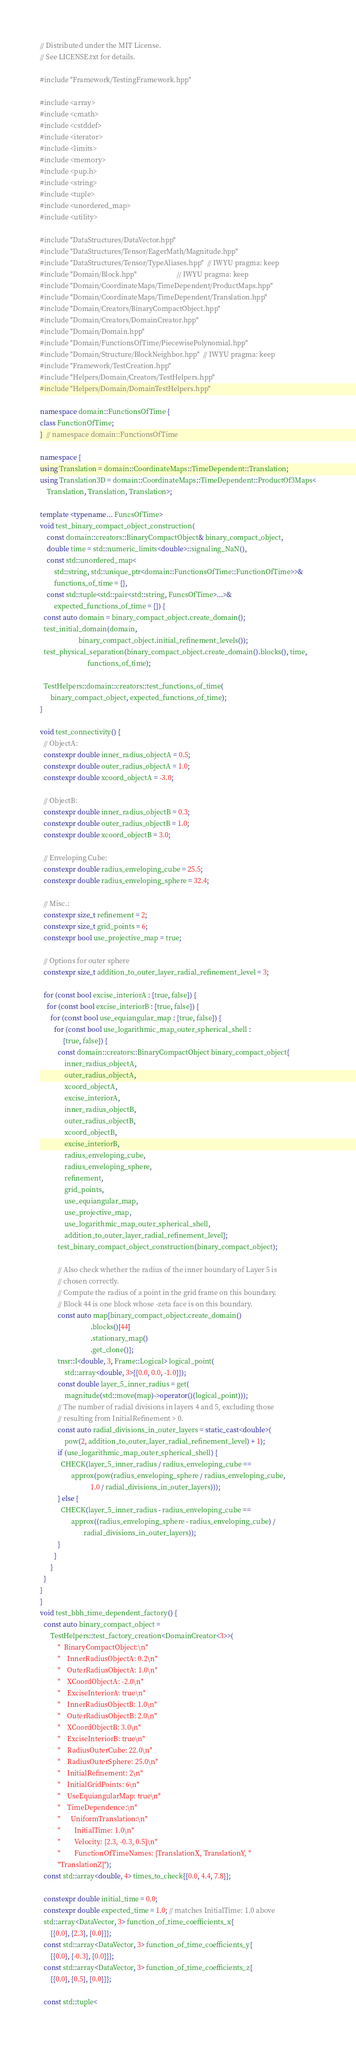Convert code to text. <code><loc_0><loc_0><loc_500><loc_500><_C++_>// Distributed under the MIT License.
// See LICENSE.txt for details.

#include "Framework/TestingFramework.hpp"

#include <array>
#include <cmath>
#include <cstddef>
#include <iterator>
#include <limits>
#include <memory>
#include <pup.h>
#include <string>
#include <tuple>
#include <unordered_map>
#include <utility>

#include "DataStructures/DataVector.hpp"
#include "DataStructures/Tensor/EagerMath/Magnitude.hpp"
#include "DataStructures/Tensor/TypeAliases.hpp"  // IWYU pragma: keep
#include "Domain/Block.hpp"                       // IWYU pragma: keep
#include "Domain/CoordinateMaps/TimeDependent/ProductMaps.hpp"
#include "Domain/CoordinateMaps/TimeDependent/Translation.hpp"
#include "Domain/Creators/BinaryCompactObject.hpp"
#include "Domain/Creators/DomainCreator.hpp"
#include "Domain/Domain.hpp"
#include "Domain/FunctionsOfTime/PiecewisePolynomial.hpp"
#include "Domain/Structure/BlockNeighbor.hpp"  // IWYU pragma: keep
#include "Framework/TestCreation.hpp"
#include "Helpers/Domain/Creators/TestHelpers.hpp"
#include "Helpers/Domain/DomainTestHelpers.hpp"

namespace domain::FunctionsOfTime {
class FunctionOfTime;
}  // namespace domain::FunctionsOfTime

namespace {
using Translation = domain::CoordinateMaps::TimeDependent::Translation;
using Translation3D = domain::CoordinateMaps::TimeDependent::ProductOf3Maps<
    Translation, Translation, Translation>;

template <typename... FuncsOfTime>
void test_binary_compact_object_construction(
    const domain::creators::BinaryCompactObject& binary_compact_object,
    double time = std::numeric_limits<double>::signaling_NaN(),
    const std::unordered_map<
        std::string, std::unique_ptr<domain::FunctionsOfTime::FunctionOfTime>>&
        functions_of_time = {},
    const std::tuple<std::pair<std::string, FuncsOfTime>...>&
        expected_functions_of_time = {}) {
  const auto domain = binary_compact_object.create_domain();
  test_initial_domain(domain,
                      binary_compact_object.initial_refinement_levels());
  test_physical_separation(binary_compact_object.create_domain().blocks(), time,
                           functions_of_time);

  TestHelpers::domain::creators::test_functions_of_time(
      binary_compact_object, expected_functions_of_time);
}

void test_connectivity() {
  // ObjectA:
  constexpr double inner_radius_objectA = 0.5;
  constexpr double outer_radius_objectA = 1.0;
  constexpr double xcoord_objectA = -3.0;

  // ObjectB:
  constexpr double inner_radius_objectB = 0.3;
  constexpr double outer_radius_objectB = 1.0;
  constexpr double xcoord_objectB = 3.0;

  // Enveloping Cube:
  constexpr double radius_enveloping_cube = 25.5;
  constexpr double radius_enveloping_sphere = 32.4;

  // Misc.:
  constexpr size_t refinement = 2;
  constexpr size_t grid_points = 6;
  constexpr bool use_projective_map = true;

  // Options for outer sphere
  constexpr size_t addition_to_outer_layer_radial_refinement_level = 3;

  for (const bool excise_interiorA : {true, false}) {
    for (const bool excise_interiorB : {true, false}) {
      for (const bool use_equiangular_map : {true, false}) {
        for (const bool use_logarithmic_map_outer_spherical_shell :
             {true, false}) {
          const domain::creators::BinaryCompactObject binary_compact_object{
              inner_radius_objectA,
              outer_radius_objectA,
              xcoord_objectA,
              excise_interiorA,
              inner_radius_objectB,
              outer_radius_objectB,
              xcoord_objectB,
              excise_interiorB,
              radius_enveloping_cube,
              radius_enveloping_sphere,
              refinement,
              grid_points,
              use_equiangular_map,
              use_projective_map,
              use_logarithmic_map_outer_spherical_shell,
              addition_to_outer_layer_radial_refinement_level};
          test_binary_compact_object_construction(binary_compact_object);

          // Also check whether the radius of the inner boundary of Layer 5 is
          // chosen correctly.
          // Compute the radius of a point in the grid frame on this boundary.
          // Block 44 is one block whose -zeta face is on this boundary.
          const auto map{binary_compact_object.create_domain()
                             .blocks()[44]
                             .stationary_map()
                             .get_clone()};
          tnsr::I<double, 3, Frame::Logical> logical_point(
              std::array<double, 3>{{0.0, 0.0, -1.0}});
          const double layer_5_inner_radius = get(
              magnitude(std::move(map)->operator()(logical_point)));
          // The number of radial divisions in layers 4 and 5, excluding those
          // resulting from InitialRefinement > 0.
          const auto radial_divisions_in_outer_layers = static_cast<double>(
              pow(2, addition_to_outer_layer_radial_refinement_level) + 1);
          if (use_logarithmic_map_outer_spherical_shell) {
            CHECK(layer_5_inner_radius / radius_enveloping_cube ==
                  approx(pow(radius_enveloping_sphere / radius_enveloping_cube,
                             1.0 / radial_divisions_in_outer_layers)));
          } else {
            CHECK(layer_5_inner_radius - radius_enveloping_cube ==
                  approx((radius_enveloping_sphere - radius_enveloping_cube) /
                         radial_divisions_in_outer_layers));
          }
        }
      }
  }
}
}
void test_bbh_time_dependent_factory() {
  const auto binary_compact_object =
      TestHelpers::test_factory_creation<DomainCreator<3>>(
          "  BinaryCompactObject:\n"
          "    InnerRadiusObjectA: 0.2\n"
          "    OuterRadiusObjectA: 1.0\n"
          "    XCoordObjectA: -2.0\n"
          "    ExciseInteriorA: true\n"
          "    InnerRadiusObjectB: 1.0\n"
          "    OuterRadiusObjectB: 2.0\n"
          "    XCoordObjectB: 3.0\n"
          "    ExciseInteriorB: true\n"
          "    RadiusOuterCube: 22.0\n"
          "    RadiusOuterSphere: 25.0\n"
          "    InitialRefinement: 2\n"
          "    InitialGridPoints: 6\n"
          "    UseEquiangularMap: true\n"
          "    TimeDependence:\n"
          "      UniformTranslation:\n"
          "        InitialTime: 1.0\n"
          "        Velocity: [2.3, -0.3, 0.5]\n"
          "        FunctionOfTimeNames: [TranslationX, TranslationY, "
          "TranslationZ]");
  const std::array<double, 4> times_to_check{{0.0, 4.4, 7.8}};

  constexpr double initial_time = 0.0;
  constexpr double expected_time = 1.0; // matches InitialTime: 1.0 above
  std::array<DataVector, 3> function_of_time_coefficients_x{
      {{0.0}, {2.3}, {0.0}}};
  const std::array<DataVector, 3> function_of_time_coefficients_y{
      {{0.0}, {-0.3}, {0.0}}};
  const std::array<DataVector, 3> function_of_time_coefficients_z{
      {{0.0}, {0.5}, {0.0}}};

  const std::tuple<</code> 